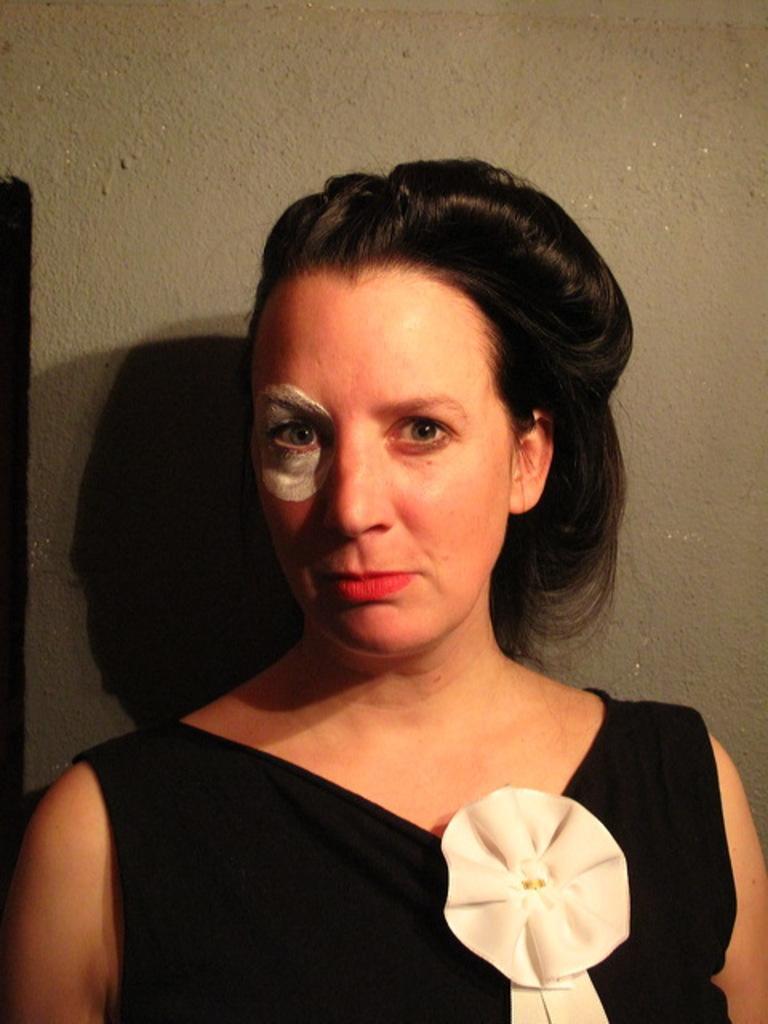How would you summarize this image in a sentence or two? A woman is present wearing a black dress. There is a white paint on her eye. 